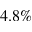Convert formula to latex. <formula><loc_0><loc_0><loc_500><loc_500>4 . 8 \%</formula> 